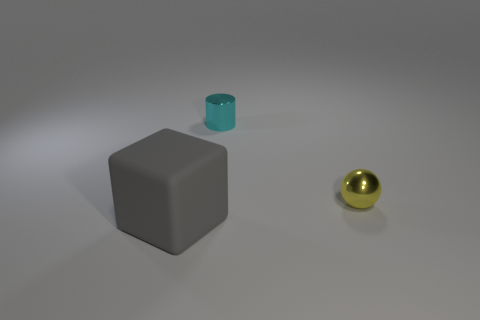Add 3 cyan metal things. How many objects exist? 6 Subtract all cylinders. How many objects are left? 2 Add 3 big gray cubes. How many big gray cubes are left? 4 Add 1 small gray metallic cylinders. How many small gray metallic cylinders exist? 1 Subtract 0 green blocks. How many objects are left? 3 Subtract all cyan cylinders. Subtract all green matte balls. How many objects are left? 2 